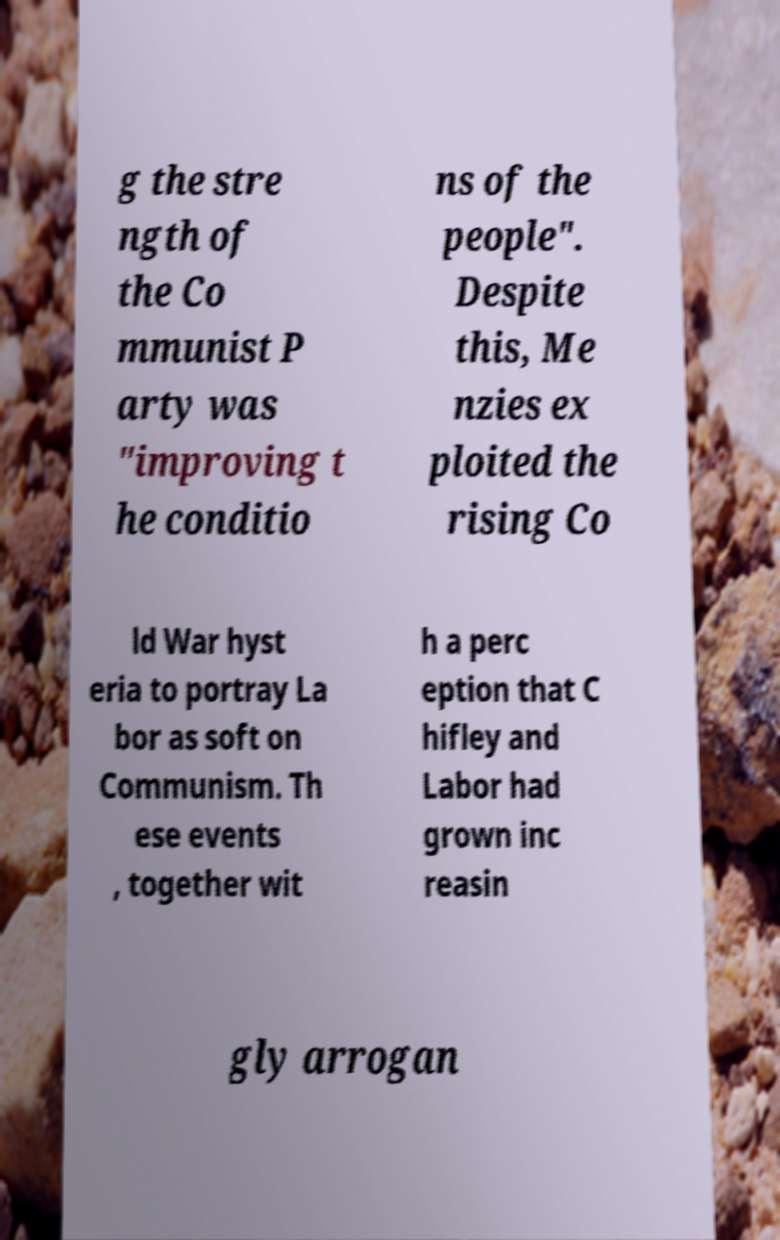For documentation purposes, I need the text within this image transcribed. Could you provide that? g the stre ngth of the Co mmunist P arty was "improving t he conditio ns of the people". Despite this, Me nzies ex ploited the rising Co ld War hyst eria to portray La bor as soft on Communism. Th ese events , together wit h a perc eption that C hifley and Labor had grown inc reasin gly arrogan 